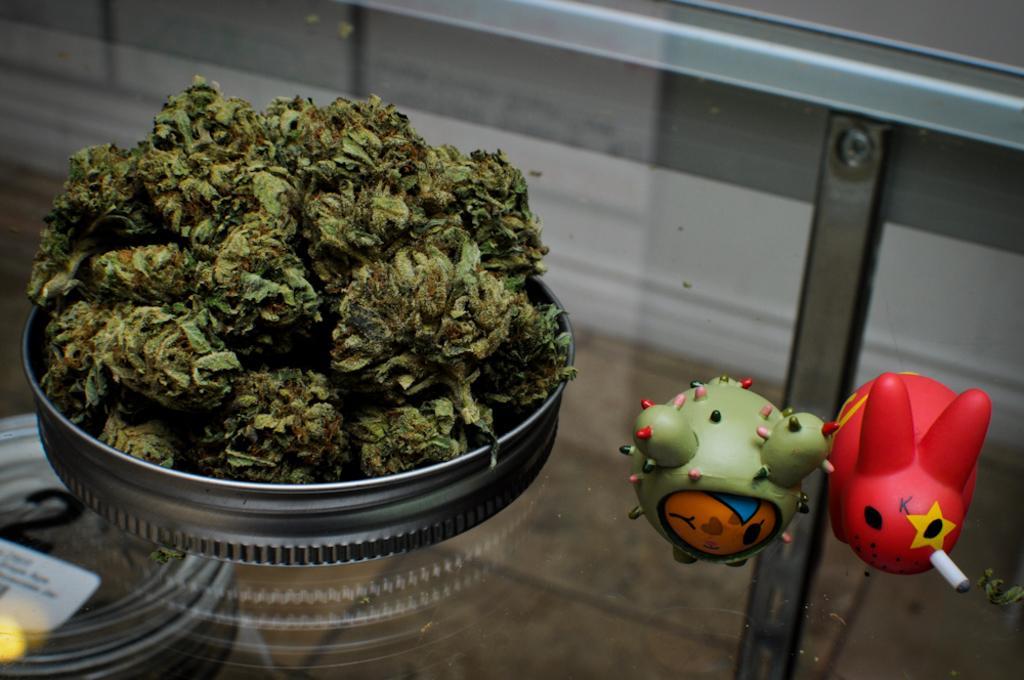Could you give a brief overview of what you see in this image? In this picture we can see food in the bowl, here we can see toys and these all are on the glass platform. 